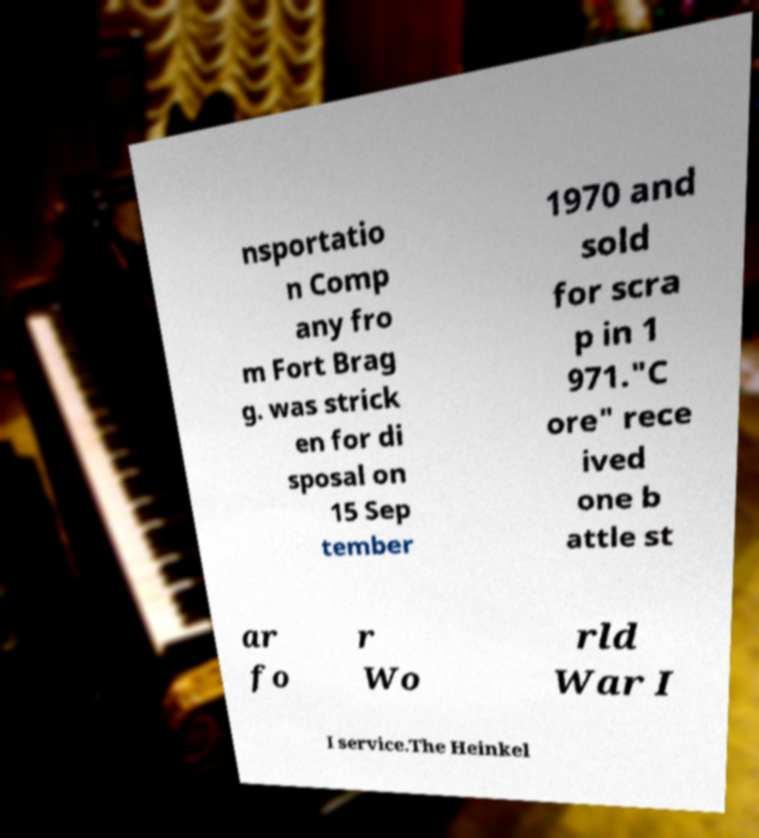Could you assist in decoding the text presented in this image and type it out clearly? nsportatio n Comp any fro m Fort Brag g. was strick en for di sposal on 15 Sep tember 1970 and sold for scra p in 1 971."C ore" rece ived one b attle st ar fo r Wo rld War I I service.The Heinkel 